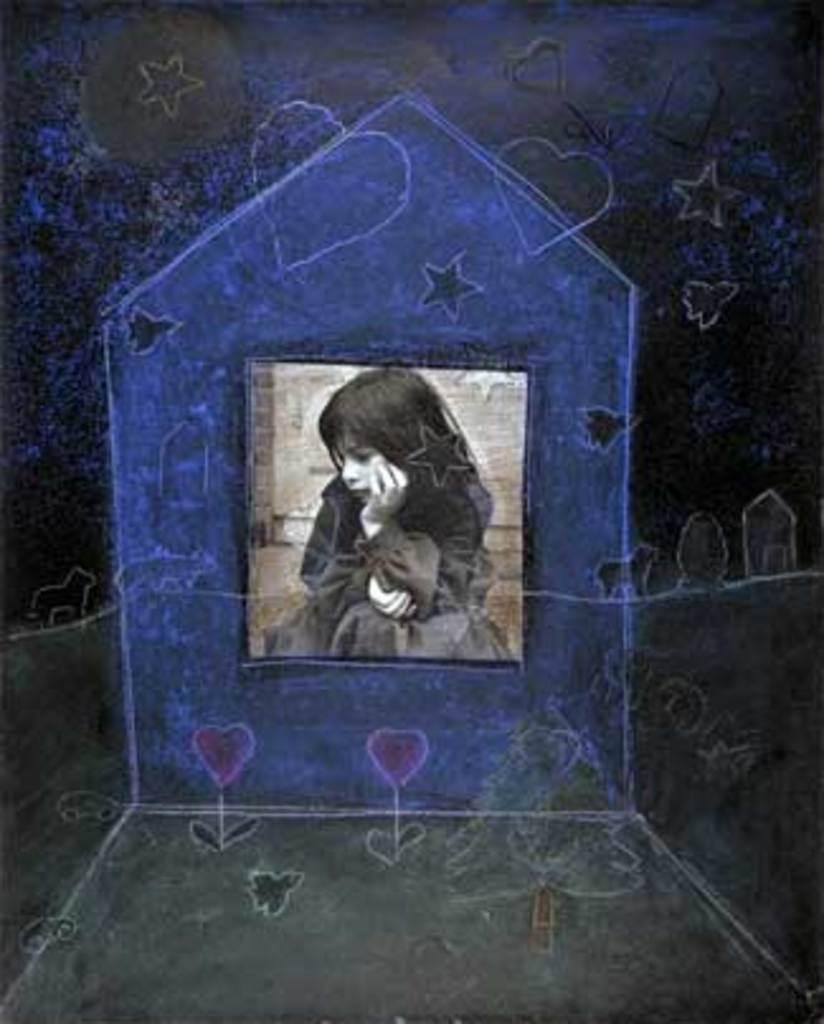What is the main subject of the image? The main subject of the image is a picture of a girl. What type of picture is it? The picture has animation. What type of chicken is depicted in the image? There is no chicken present in the image; it features a picture of a girl with animation. What type of motion can be seen in the image? The motion in the image is limited to the animation of the girl's picture; there is no other motion depicted. 